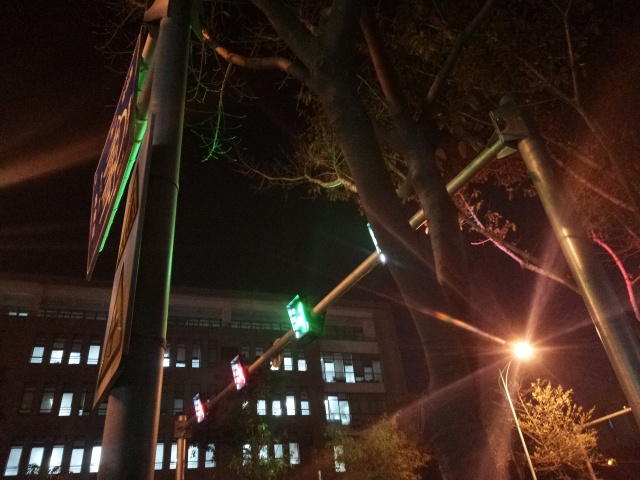What time of day does this photo seem to be taken, and what mood does it evoke? The photo appears to have been taken at night, as evidenced by the dark sky and artificial lighting. The mood evoked is one of stillness and quietness, typical of a cityscape after hours when the bustle of the day has subsided. 